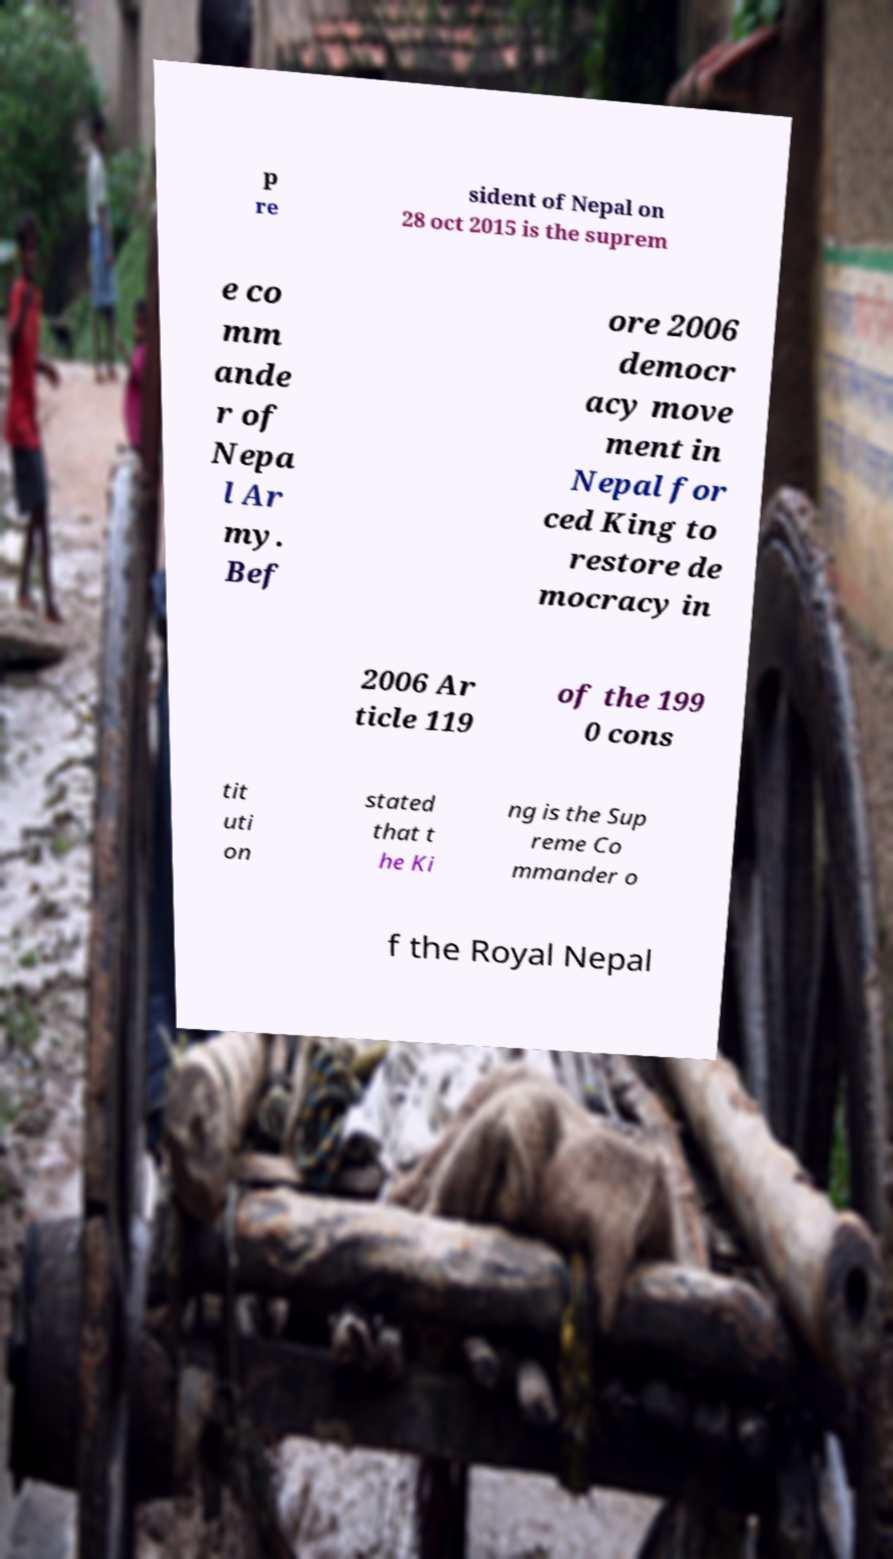Please read and relay the text visible in this image. What does it say? p re sident of Nepal on 28 oct 2015 is the suprem e co mm ande r of Nepa l Ar my. Bef ore 2006 democr acy move ment in Nepal for ced King to restore de mocracy in 2006 Ar ticle 119 of the 199 0 cons tit uti on stated that t he Ki ng is the Sup reme Co mmander o f the Royal Nepal 